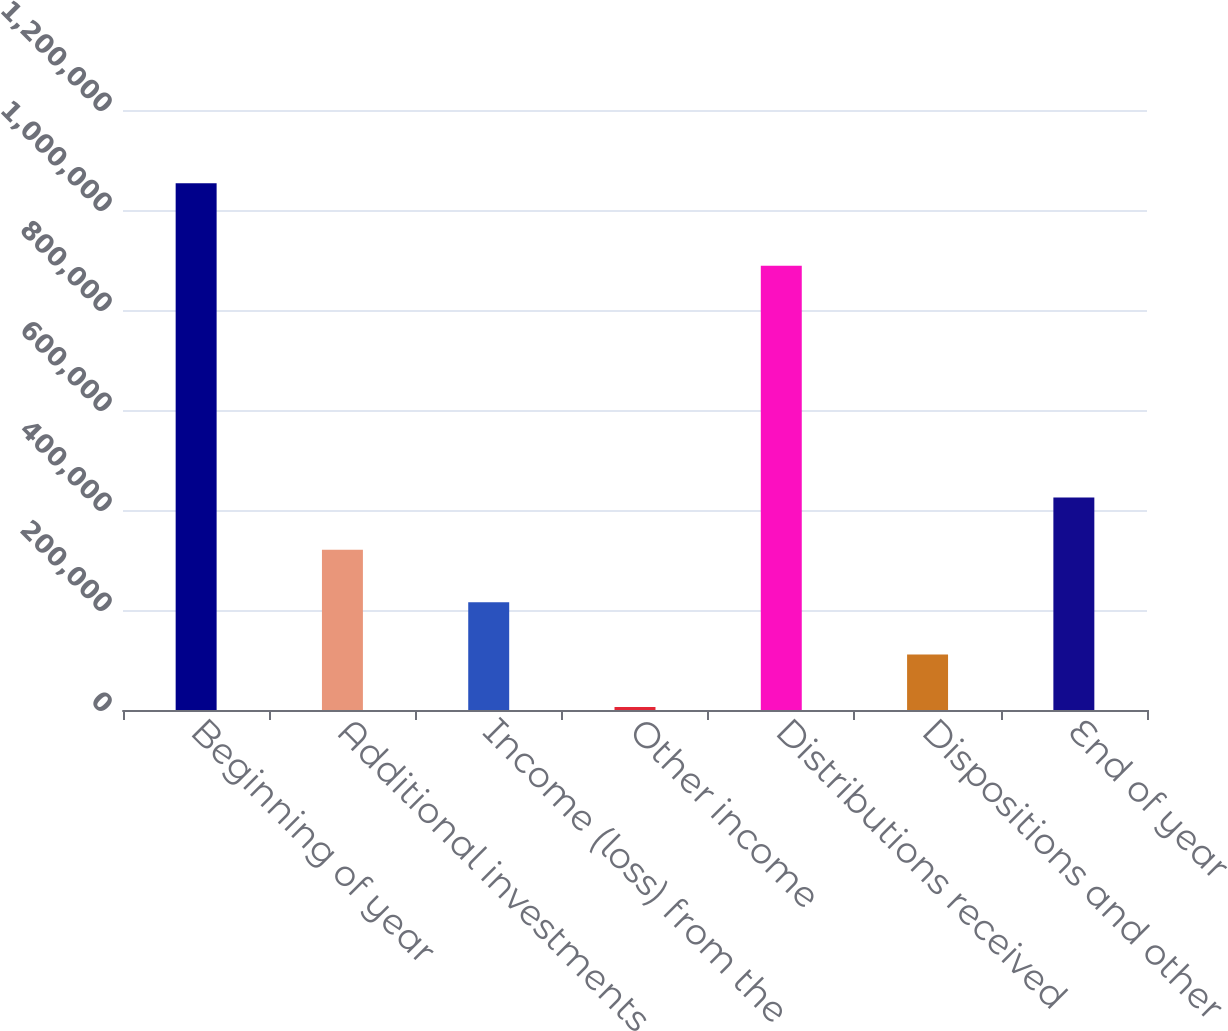Convert chart. <chart><loc_0><loc_0><loc_500><loc_500><bar_chart><fcel>Beginning of year<fcel>Additional investments<fcel>Income (loss) from the<fcel>Other income<fcel>Distributions received<fcel>Dispositions and other<fcel>End of year<nl><fcel>1.05333e+06<fcel>320361<fcel>215651<fcel>6232<fcel>888260<fcel>110942<fcel>425070<nl></chart> 